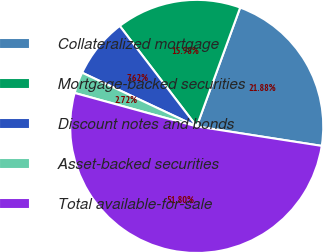Convert chart to OTSL. <chart><loc_0><loc_0><loc_500><loc_500><pie_chart><fcel>Collateralized mortgage<fcel>Mortgage-backed securities<fcel>Discount notes and bonds<fcel>Asset-backed securities<fcel>Total available-for-sale<nl><fcel>21.88%<fcel>15.98%<fcel>7.62%<fcel>2.72%<fcel>51.8%<nl></chart> 